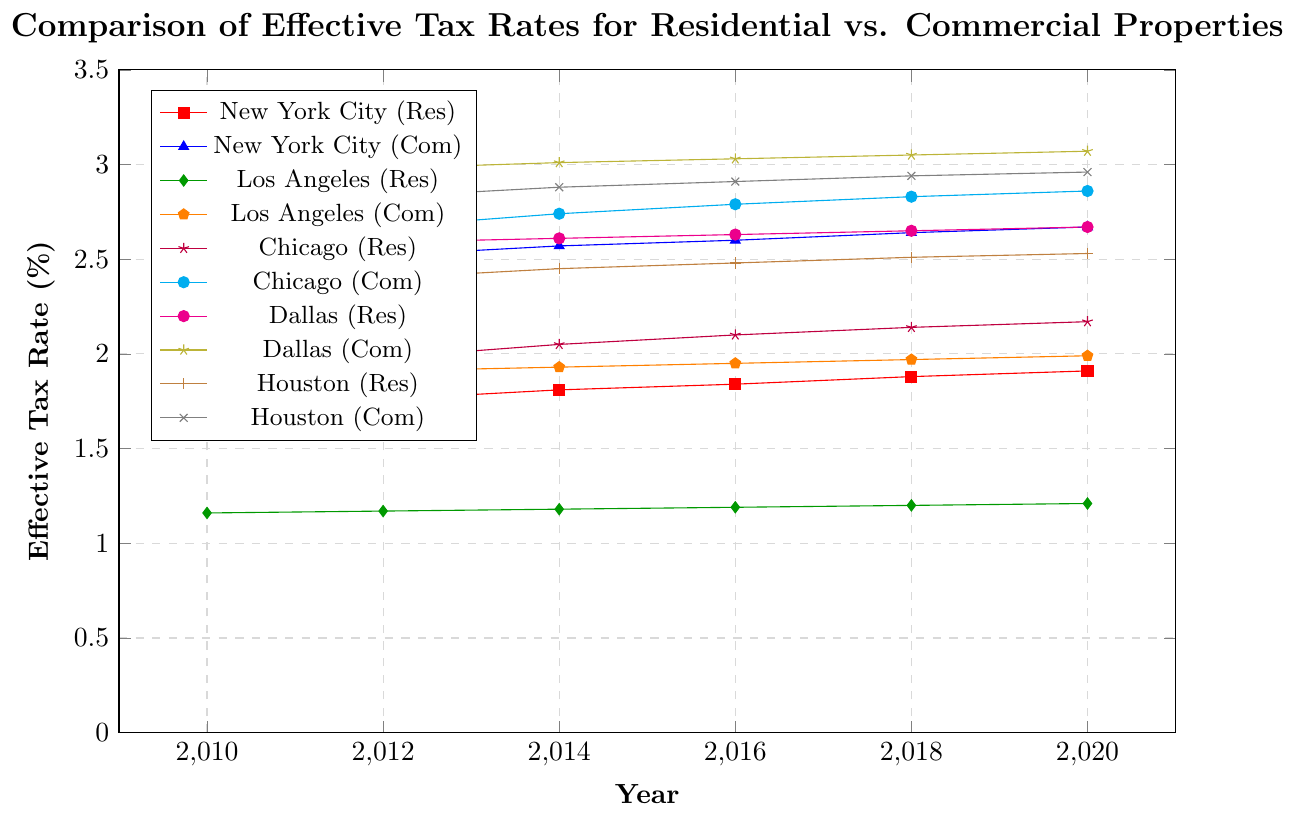What is the difference in the effective tax rates for residential and commercial properties in New York City in 2010? To find the difference in tax rates for residential and commercial properties, subtract the residential rate from the commercial rate for New York City in 2010: 2.48% - 1.72% = 0.76%
Answer: 0.76% How did the effective tax rate for residential properties in Chicago change from 2010 to 2020? To find the change in the tax rate, subtract the tax rate in 2010 from the tax rate in 2020 for residential properties in Chicago: 2.17% - 1.84% = 0.33%
Answer: 0.33% Which city had the highest effective tax rate for commercial properties in 2020? Looking at the commercial rates in 2020, Dallas has the highest rate at 3.07%
Answer: Dallas Did any cities have higher effective tax rates for residential properties compared to commercial properties in any year? By inspecting the figure, none of the cities have higher residential tax rates compared to their commercial rates in any year
Answer: No What is the average effective tax rate for residential properties in New York City from 2010 to 2020? To calculate the average, add the residential rates from 2010 to 2020 and divide by the number of years: (1.72 + 1.76 + 1.81 + 1.84 + 1.88 + 1.91) / 6 = 1.82%
Answer: 1.82% How does the trend of effective tax rates for commercial properties in Los Angeles compare to residential properties from 2010 to 2020? Both commercial and residential tax rates in Los Angeles show a similar upward trend from 2010 to 2020, with commercial rates increasing from 1.89% to 1.99% and residential rates from 1.16% to 1.21%
Answer: Both trending upward What is the overall range of effective tax rates for residential properties across all cities in 2020? The lowest rate for residential properties is in Washington DC at 0.89% and the highest is in Dallas at 2.67%. The overall range is 2.67% - 0.89% = 1.78%
Answer: 1.78% Compare the effective tax rates for commercial properties in Houston and Miami in 2018. The effective tax rate in Houston is 2.94%, while in Miami it is 2.60%. Houston has a higher rate: 2.94% - 2.60% = 0.34%
Answer: Houston is higher by 0.34% Which city has the smallest increase in effective tax rates for residential properties from 2010 to 2020? By looking at the increase in residential rates over the years, Los Angeles increased the least: 1.21% - 1.16% = 0.05%
Answer: Los Angeles What can be inferred about the relationship between residential and commercial property tax rates over time? Generally, commercial tax rates are higher than residential rates in all cities and both types of rates tend to increase over the years
Answer: Commercial rates higher, both increasing 